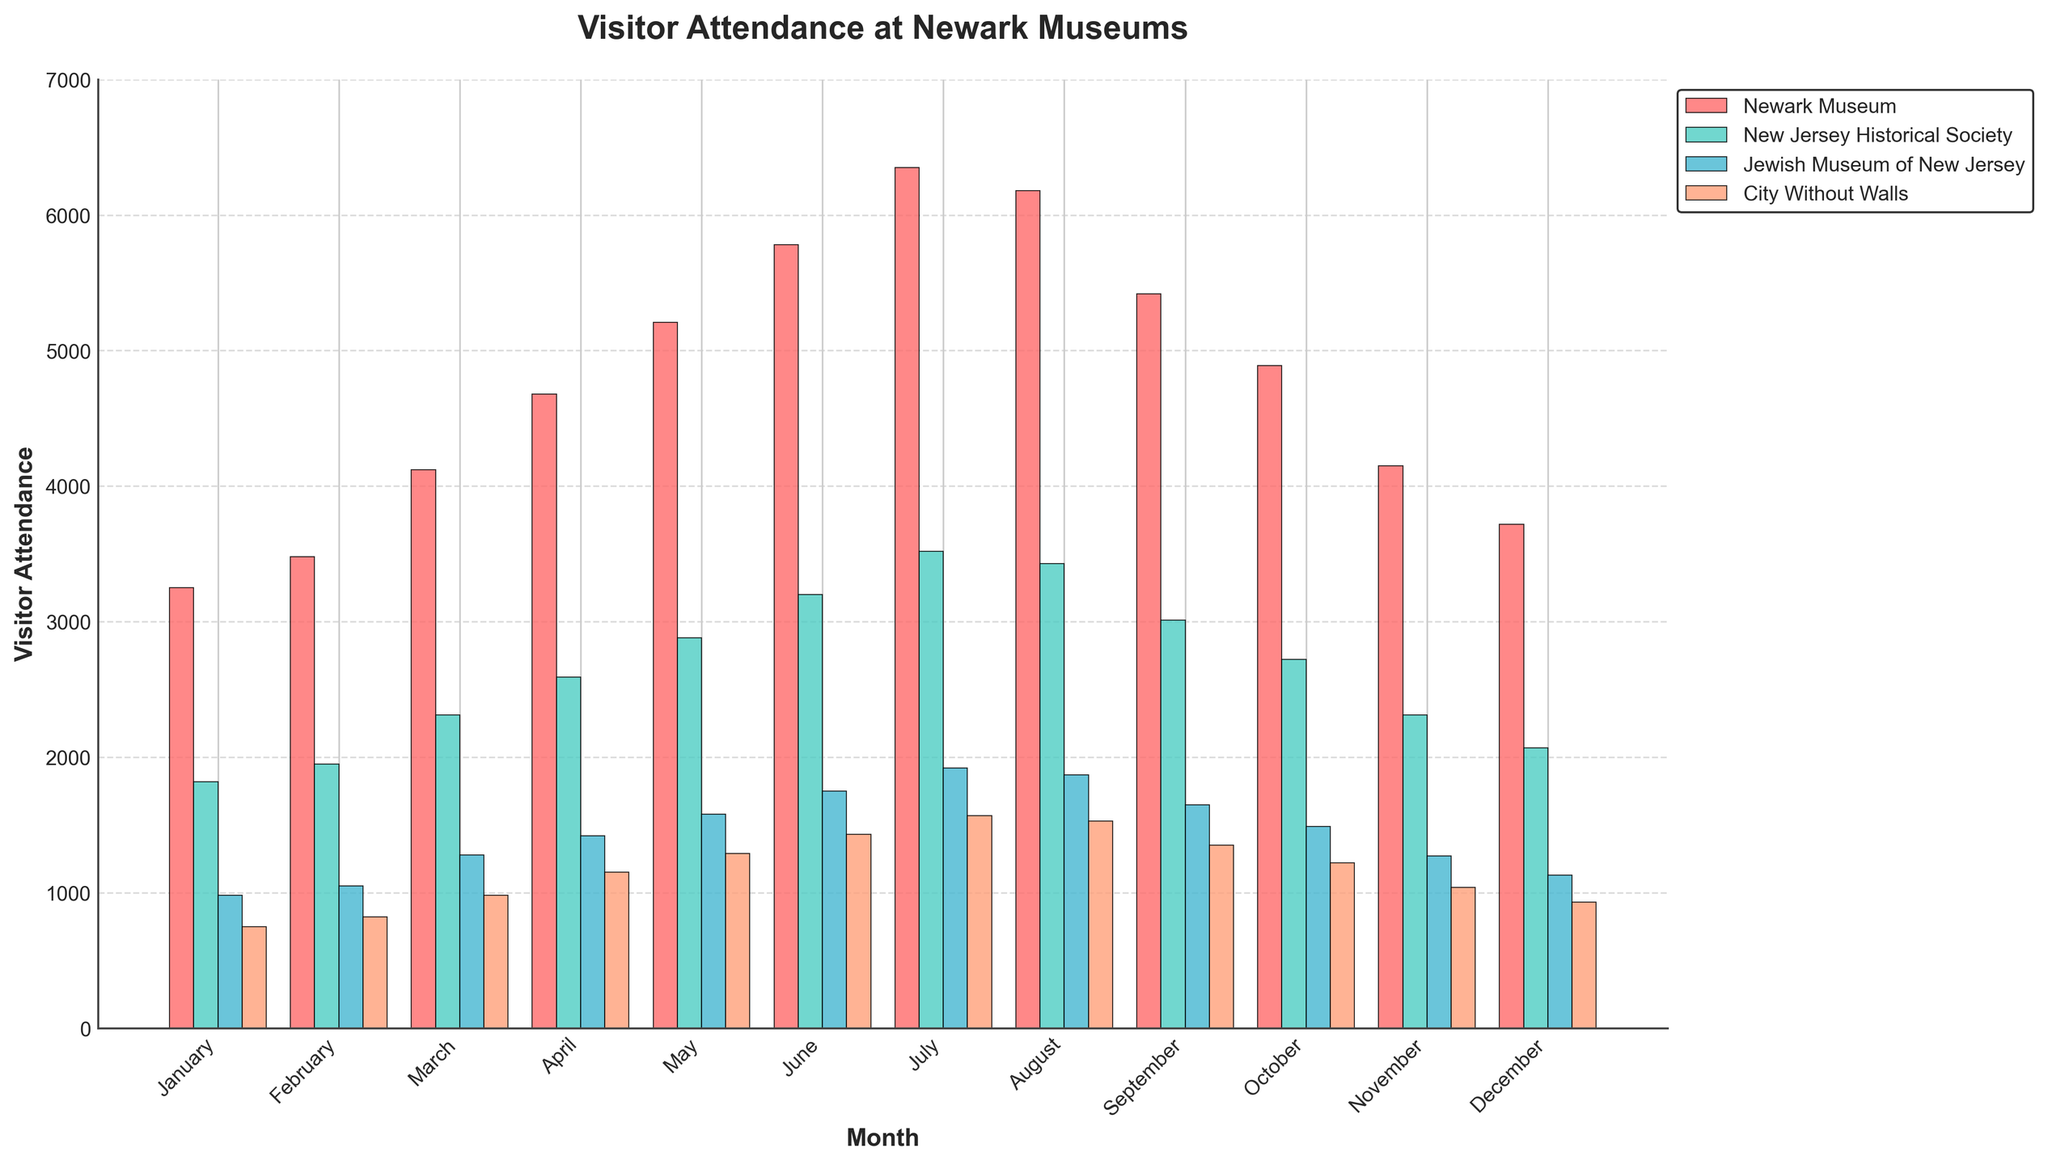Which month had the highest visitor attendance at the Newark Museum? We need to identify the month with the tallest red bar representing the Newark Museum. In July, the Newark Museum had the highest attendance.
Answer: July Which museum had the least visitors in December? Look for the shortest bar in December, regardless of color. The shortest bar in December represents City Without Walls.
Answer: City Without Walls What was the difference in visitor attendance between June and August at the Jewish Museum of New Jersey? Subtract the August visitor count from the June visitor count for the Jewish Museum of New Jersey. The attendance in June is 1750 and in August is 1870, so the difference is 1870-1750 = 120.
Answer: 120 In which month did the New Jersey Historical Society have the smallest increase in visitors compared to the previous month? We need to calculate the difference in attendance for each consecutive month and find the smallest positive change. The smallest increase is between August (3430) and September (3010), which is -420.
Answer: September Which month saw the highest combined visitor attendance across all four museums? Sum the heights of all bars (all the visitor counts) for each month and identify the tallest grouped bars. The month with the highest combined attendance is July.
Answer: July How does visitor attendance in January at City Without Walls compare to visitor attendance in January at the Jewish Museum of New Jersey? Compare the height of the blue bar with the yellow bar in January. The Jewish Museum of New Jersey had higher attendance than City Without Walls (980 vs. 750).
Answer: Jewish Museum of New Jersey had higher attendance What is the average visitor attendance at City Without Walls from January to March? Sum the visitor counts for City Without Walls from January to March and divide by 3. (750 + 820 + 980) / 3 = 850.
Answer: 850 How does the visitor trend at the Newark Museum from January to June compare to the New Jersey Historical Society for the same period? Both trends show increasing visitor attendance, but the Newark Museum has a steeper increase than the New Jersey Historical Society.
Answer: Increasing trend, more steeply for Newark Museum 